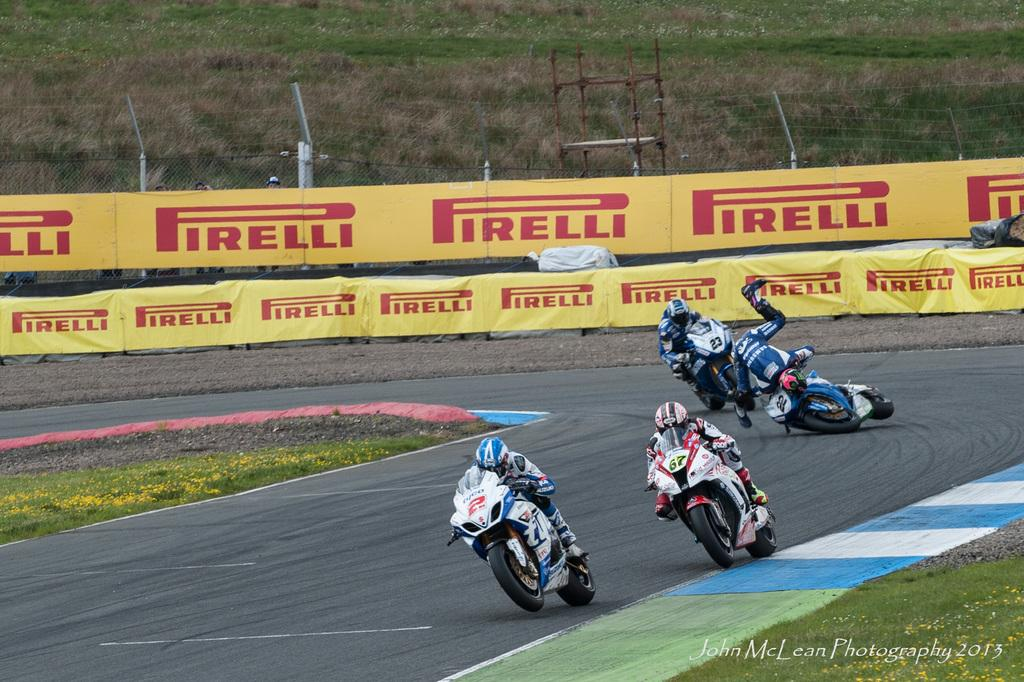What are the people in the image doing? The people in the image are riding bikes. What can be seen in the background of the image? There are yellow boards in the background of the image. What type of terrain is visible in the image? There is green grass visible in the image. What type of glove is being used by the people riding bikes in the image? There is no glove visible in the image; the people are riding bikes without gloves. 